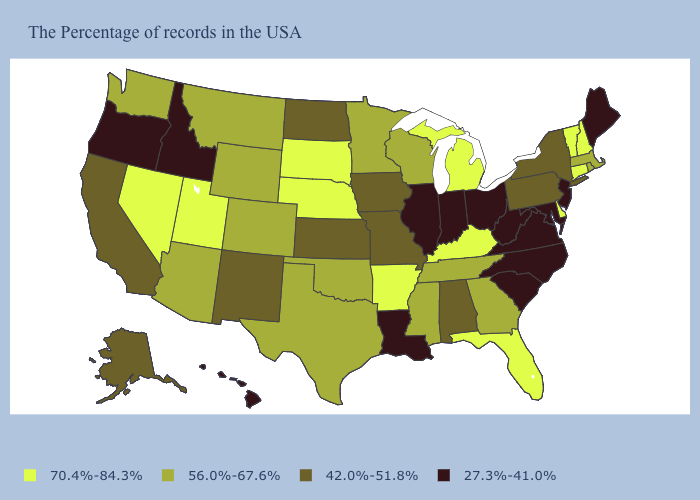What is the value of California?
Short answer required. 42.0%-51.8%. Does the first symbol in the legend represent the smallest category?
Be succinct. No. What is the highest value in the West ?
Concise answer only. 70.4%-84.3%. Does the first symbol in the legend represent the smallest category?
Concise answer only. No. What is the value of Arkansas?
Concise answer only. 70.4%-84.3%. Does the map have missing data?
Concise answer only. No. Does the map have missing data?
Short answer required. No. What is the value of Tennessee?
Keep it brief. 56.0%-67.6%. Among the states that border Missouri , does Oklahoma have the highest value?
Answer briefly. No. Name the states that have a value in the range 42.0%-51.8%?
Concise answer only. New York, Pennsylvania, Alabama, Missouri, Iowa, Kansas, North Dakota, New Mexico, California, Alaska. What is the highest value in the MidWest ?
Give a very brief answer. 70.4%-84.3%. What is the value of California?
Write a very short answer. 42.0%-51.8%. Does North Carolina have the lowest value in the USA?
Concise answer only. Yes. Which states have the lowest value in the Northeast?
Quick response, please. Maine, New Jersey. What is the value of Pennsylvania?
Answer briefly. 42.0%-51.8%. 